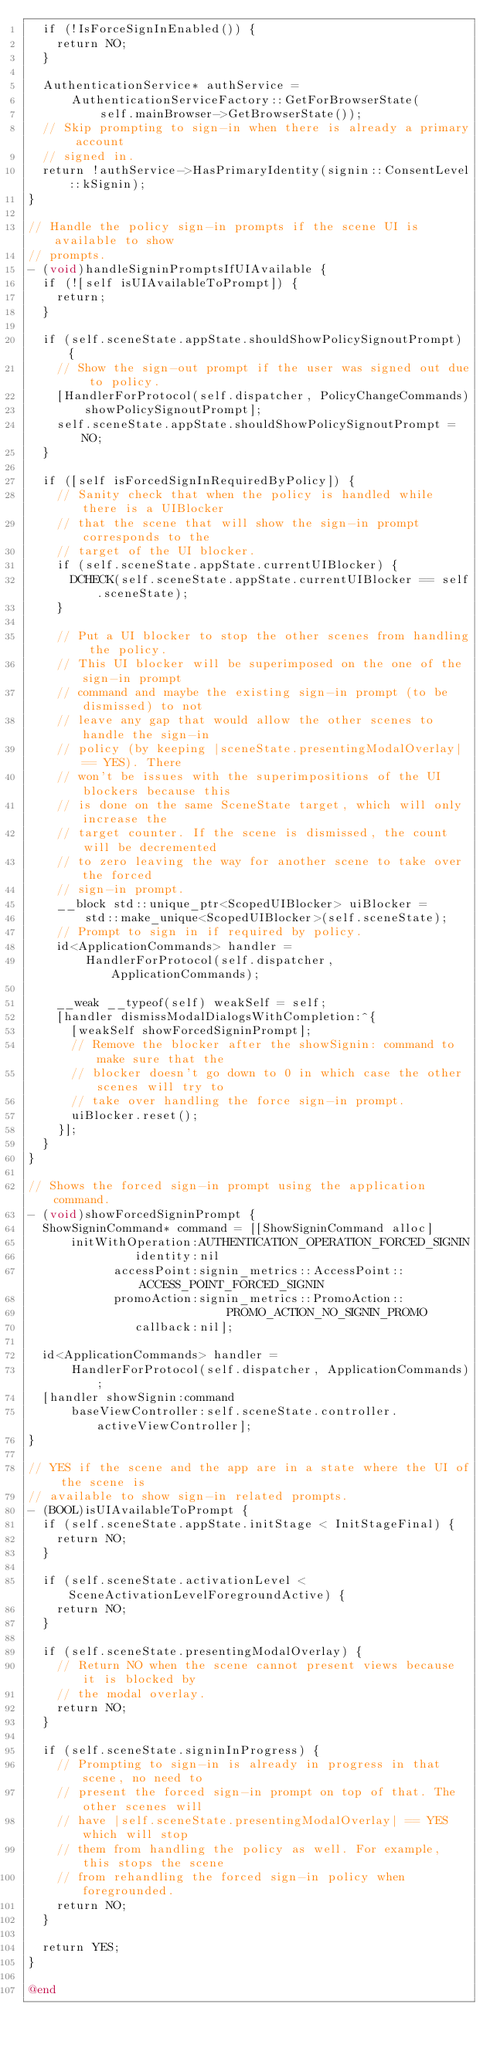<code> <loc_0><loc_0><loc_500><loc_500><_ObjectiveC_>  if (!IsForceSignInEnabled()) {
    return NO;
  }

  AuthenticationService* authService =
      AuthenticationServiceFactory::GetForBrowserState(
          self.mainBrowser->GetBrowserState());
  // Skip prompting to sign-in when there is already a primary account
  // signed in.
  return !authService->HasPrimaryIdentity(signin::ConsentLevel::kSignin);
}

// Handle the policy sign-in prompts if the scene UI is available to show
// prompts.
- (void)handleSigninPromptsIfUIAvailable {
  if (![self isUIAvailableToPrompt]) {
    return;
  }

  if (self.sceneState.appState.shouldShowPolicySignoutPrompt) {
    // Show the sign-out prompt if the user was signed out due to policy.
    [HandlerForProtocol(self.dispatcher, PolicyChangeCommands)
        showPolicySignoutPrompt];
    self.sceneState.appState.shouldShowPolicySignoutPrompt = NO;
  }

  if ([self isForcedSignInRequiredByPolicy]) {
    // Sanity check that when the policy is handled while there is a UIBlocker
    // that the scene that will show the sign-in prompt corresponds to the
    // target of the UI blocker.
    if (self.sceneState.appState.currentUIBlocker) {
      DCHECK(self.sceneState.appState.currentUIBlocker == self.sceneState);
    }

    // Put a UI blocker to stop the other scenes from handling the policy.
    // This UI blocker will be superimposed on the one of the sign-in prompt
    // command and maybe the existing sign-in prompt (to be dismissed) to not
    // leave any gap that would allow the other scenes to handle the sign-in
    // policy (by keeping |sceneState.presentingModalOverlay| == YES). There
    // won't be issues with the superimpositions of the UI blockers because this
    // is done on the same SceneState target, which will only increase the
    // target counter. If the scene is dismissed, the count will be decremented
    // to zero leaving the way for another scene to take over the forced
    // sign-in prompt.
    __block std::unique_ptr<ScopedUIBlocker> uiBlocker =
        std::make_unique<ScopedUIBlocker>(self.sceneState);
    // Prompt to sign in if required by policy.
    id<ApplicationCommands> handler =
        HandlerForProtocol(self.dispatcher, ApplicationCommands);

    __weak __typeof(self) weakSelf = self;
    [handler dismissModalDialogsWithCompletion:^{
      [weakSelf showForcedSigninPrompt];
      // Remove the blocker after the showSignin: command to make sure that the
      // blocker doesn't go down to 0 in which case the other scenes will try to
      // take over handling the force sign-in prompt.
      uiBlocker.reset();
    }];
  }
}

// Shows the forced sign-in prompt using the application command.
- (void)showForcedSigninPrompt {
  ShowSigninCommand* command = [[ShowSigninCommand alloc]
      initWithOperation:AUTHENTICATION_OPERATION_FORCED_SIGNIN
               identity:nil
            accessPoint:signin_metrics::AccessPoint::ACCESS_POINT_FORCED_SIGNIN
            promoAction:signin_metrics::PromoAction::
                            PROMO_ACTION_NO_SIGNIN_PROMO
               callback:nil];

  id<ApplicationCommands> handler =
      HandlerForProtocol(self.dispatcher, ApplicationCommands);
  [handler showSignin:command
      baseViewController:self.sceneState.controller.activeViewController];
}

// YES if the scene and the app are in a state where the UI of the scene is
// available to show sign-in related prompts.
- (BOOL)isUIAvailableToPrompt {
  if (self.sceneState.appState.initStage < InitStageFinal) {
    return NO;
  }

  if (self.sceneState.activationLevel < SceneActivationLevelForegroundActive) {
    return NO;
  }

  if (self.sceneState.presentingModalOverlay) {
    // Return NO when the scene cannot present views because it is blocked by
    // the modal overlay.
    return NO;
  }

  if (self.sceneState.signinInProgress) {
    // Prompting to sign-in is already in progress in that scene, no need to
    // present the forced sign-in prompt on top of that. The other scenes will
    // have |self.sceneState.presentingModalOverlay| == YES which will stop
    // them from handling the policy as well. For example, this stops the scene
    // from rehandling the forced sign-in policy when foregrounded.
    return NO;
  }

  return YES;
}

@end
</code> 